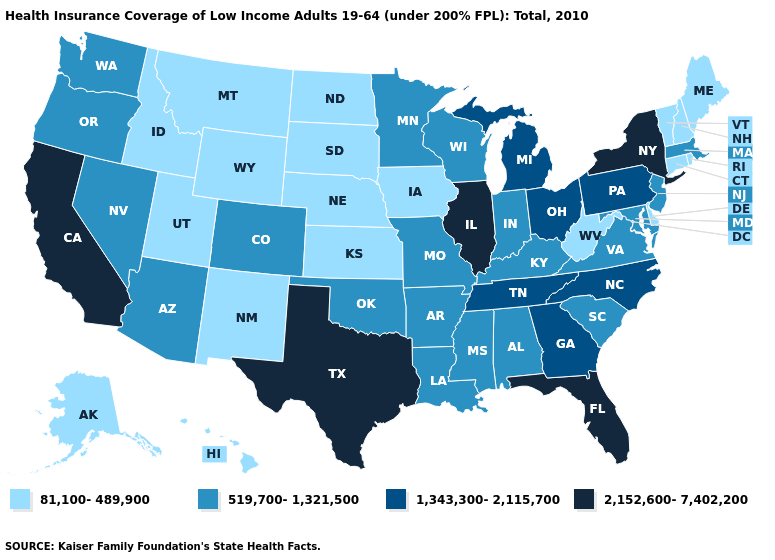Does Michigan have a lower value than Texas?
Keep it brief. Yes. What is the value of Connecticut?
Be succinct. 81,100-489,900. Does the map have missing data?
Short answer required. No. Does Indiana have a higher value than Wisconsin?
Short answer required. No. Does Maryland have the highest value in the South?
Keep it brief. No. Which states have the lowest value in the USA?
Give a very brief answer. Alaska, Connecticut, Delaware, Hawaii, Idaho, Iowa, Kansas, Maine, Montana, Nebraska, New Hampshire, New Mexico, North Dakota, Rhode Island, South Dakota, Utah, Vermont, West Virginia, Wyoming. Name the states that have a value in the range 519,700-1,321,500?
Concise answer only. Alabama, Arizona, Arkansas, Colorado, Indiana, Kentucky, Louisiana, Maryland, Massachusetts, Minnesota, Mississippi, Missouri, Nevada, New Jersey, Oklahoma, Oregon, South Carolina, Virginia, Washington, Wisconsin. Among the states that border Missouri , which have the lowest value?
Concise answer only. Iowa, Kansas, Nebraska. What is the highest value in the MidWest ?
Write a very short answer. 2,152,600-7,402,200. Among the states that border Missouri , does Iowa have the lowest value?
Give a very brief answer. Yes. Does Missouri have the lowest value in the USA?
Short answer required. No. What is the lowest value in states that border Connecticut?
Concise answer only. 81,100-489,900. Does Arizona have the lowest value in the USA?
Be succinct. No. Which states have the highest value in the USA?
Write a very short answer. California, Florida, Illinois, New York, Texas. What is the value of Iowa?
Be succinct. 81,100-489,900. 